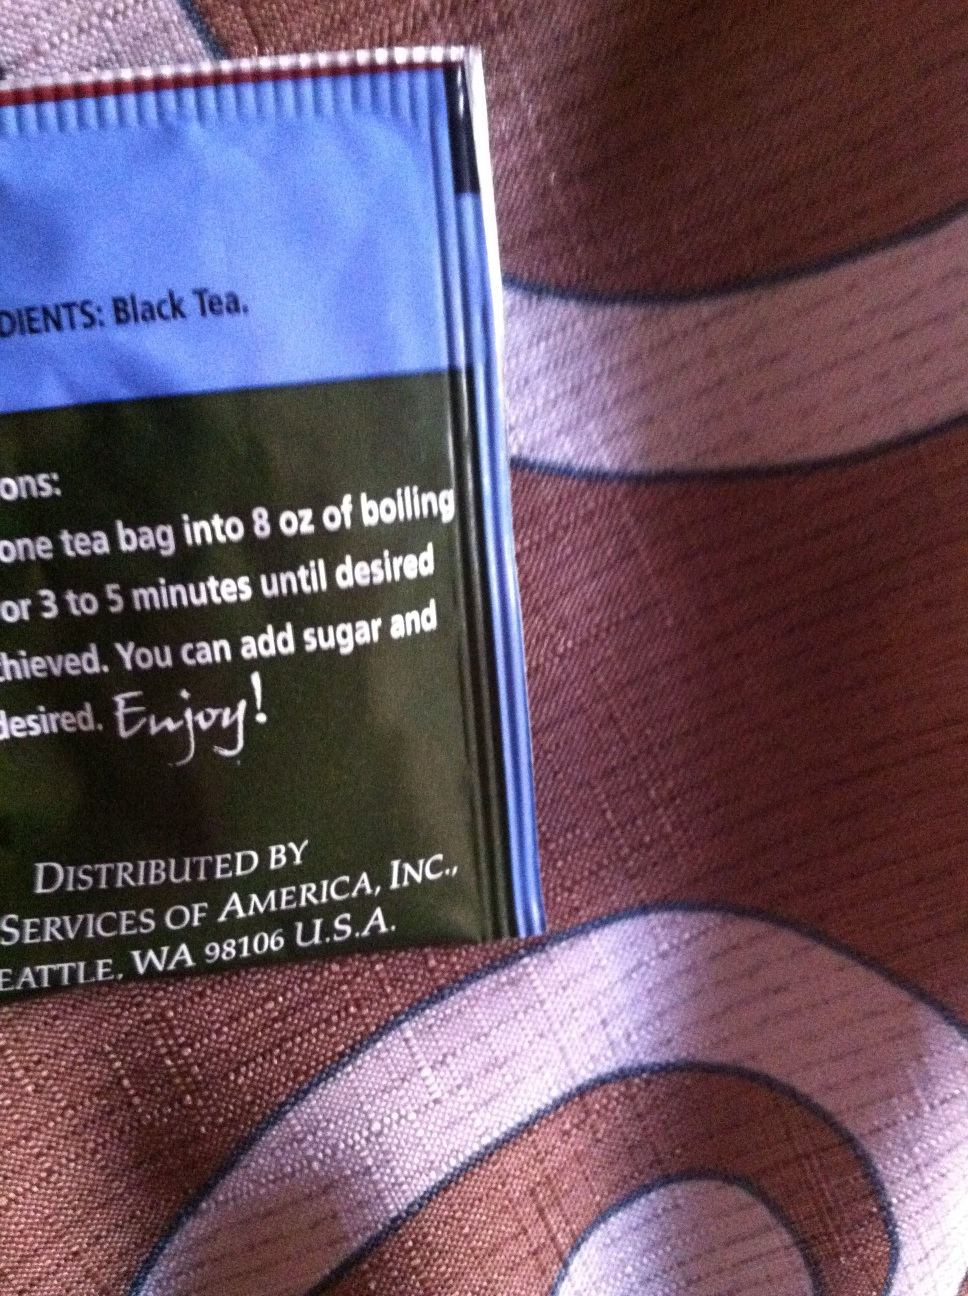Can you tell me more about how to prepare this tea? Certainly! To prepare this black tea, steep one tea bag in 8 oz of boiling water for 3 to 5 minutes. Depending on your taste preference, you can add sugar and other condiments to enhance the flavor. It's perfect for a comforting warm drink. 